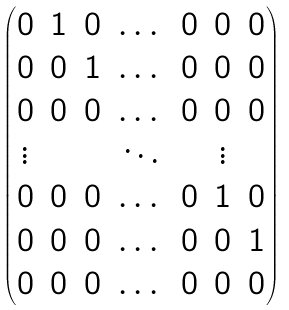<formula> <loc_0><loc_0><loc_500><loc_500>\begin{pmatrix} 0 & 1 & 0 & \dots & 0 & 0 & 0 \\ 0 & 0 & 1 & \dots & 0 & 0 & 0 \\ 0 & 0 & 0 & \dots & 0 & 0 & 0 \\ \vdots & & & \ddots & & \vdots \\ 0 & 0 & 0 & \dots & 0 & 1 & 0 \\ 0 & 0 & 0 & \dots & 0 & 0 & 1 \\ 0 & 0 & 0 & \dots & 0 & 0 & 0 \end{pmatrix}</formula> 